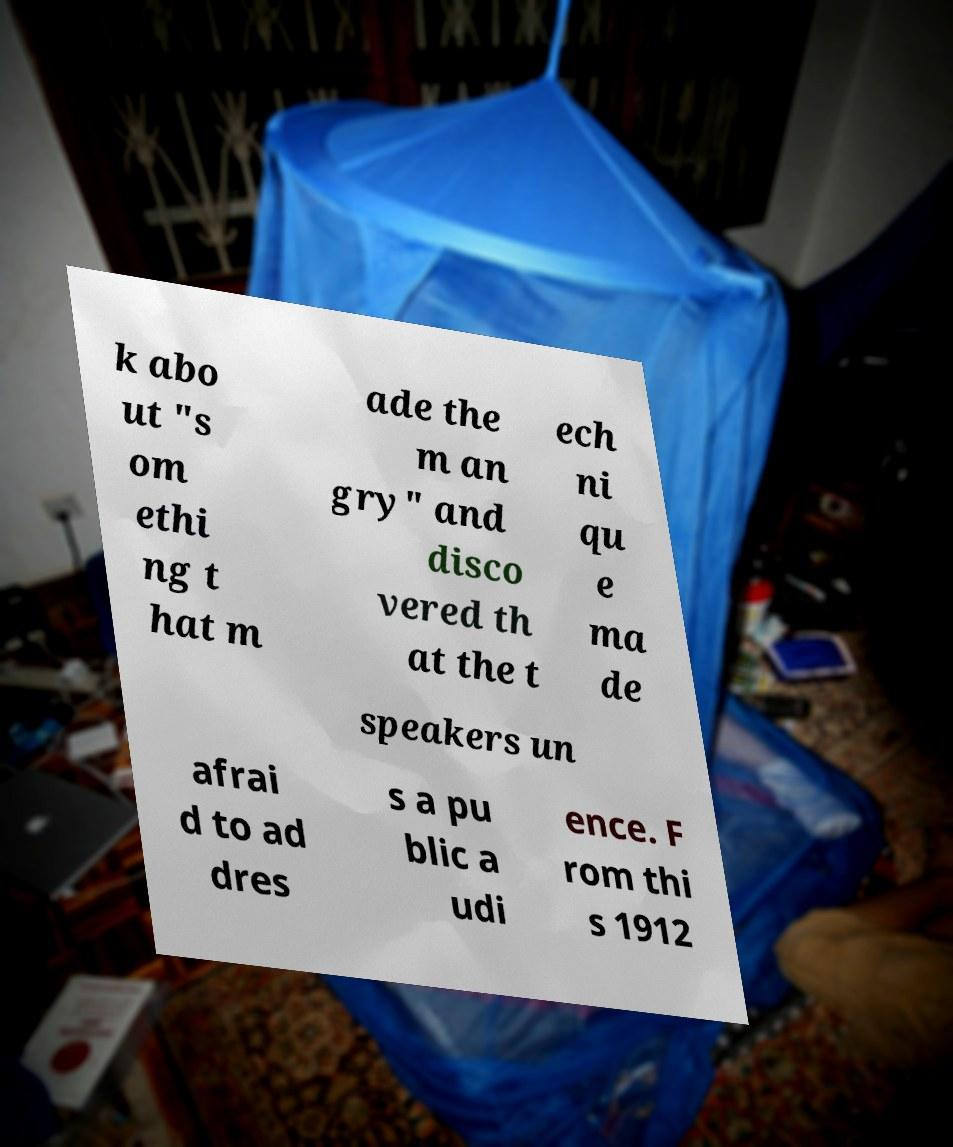Can you read and provide the text displayed in the image?This photo seems to have some interesting text. Can you extract and type it out for me? k abo ut "s om ethi ng t hat m ade the m an gry" and disco vered th at the t ech ni qu e ma de speakers un afrai d to ad dres s a pu blic a udi ence. F rom thi s 1912 